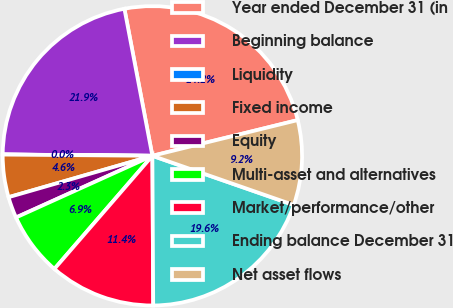<chart> <loc_0><loc_0><loc_500><loc_500><pie_chart><fcel>Year ended December 31 (in<fcel>Beginning balance<fcel>Liquidity<fcel>Fixed income<fcel>Equity<fcel>Multi-asset and alternatives<fcel>Market/performance/other<fcel>Ending balance December 31<fcel>Net asset flows<nl><fcel>24.16%<fcel>21.87%<fcel>0.01%<fcel>4.59%<fcel>2.3%<fcel>6.88%<fcel>11.45%<fcel>19.58%<fcel>9.17%<nl></chart> 